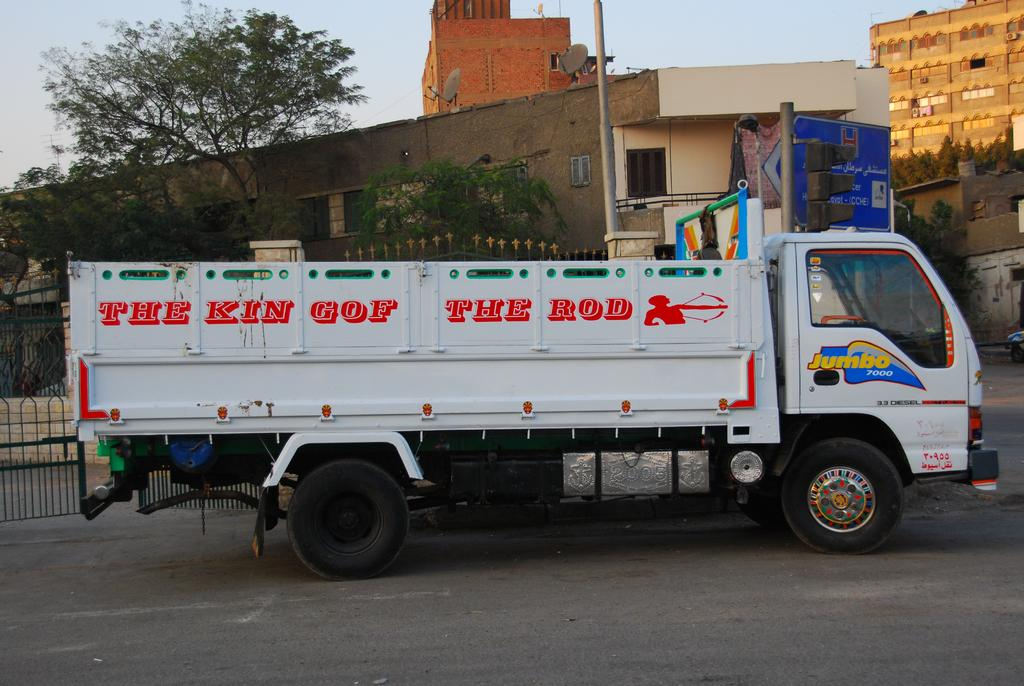<image>
Describe the image concisely. A large white truck with words written on the side in red saying The Kin Gof The Rod. 